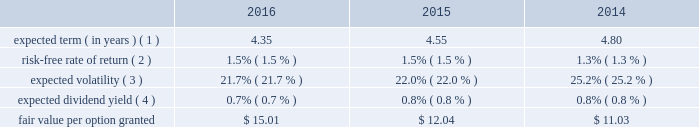Visa inc .
Notes to consolidated financial statements 2014 ( continued ) september 30 , 2016 note 16 2014share-based compensation 2007 equity incentive compensation plan the company 2019s 2007 equity incentive compensation plan , or the eip , authorizes the compensation committee of the board of directors to grant non-qualified stock options ( 201coptions 201d ) , restricted stock awards ( 201crsas 201d ) , restricted stock units ( 201crsus 201d ) and performance-based shares to its employees and non-employee directors , for up to 236 million shares of class a common stock .
Shares available for award may be either authorized and unissued or previously issued shares subsequently acquired by the company .
The eip will continue to be in effect until all of the common stock available under the eip is delivered and all restrictions on those shares have lapsed , unless the eip is terminated earlier by the company 2019s board of directors .
In january 2016 , the company 2019s board of directors approved an amendment of the eip effective february 3 , 2016 , such that awards may be granted under the plan until january 31 , 2022 .
Share-based compensation cost is recorded net of estimated forfeitures on a straight-line basis for awards with service conditions only , and on a graded-vesting basis for awards with service , performance and market conditions .
The company 2019s estimated forfeiture rate is based on an evaluation of historical , actual and trended forfeiture data .
For fiscal 2016 , 2015 and 2014 , the company recorded share-based compensation cost related to the eip of $ 211 million , $ 184 million and $ 172 million , respectively , in personnel on its consolidated statements of operations .
The related tax benefits were $ 62 million , $ 54 million and $ 51 million for fiscal 2016 , 2015 and 2014 , respectively .
The amount of capitalized share-based compensation cost was immaterial during fiscal 2016 , 2015 and all per share amounts and number of shares outstanding presented below reflect the four-for-one stock split that was effected in the second quarter of fiscal 2015 .
See note 14 2014stockholders 2019 equity .
Options options issued under the eip expire 10 years from the date of grant and primarily vest ratably over 3 years from the date of grant , subject to earlier vesting in full under certain conditions .
During fiscal 2016 , 2015 and 2014 , the fair value of each stock option was estimated on the date of grant using a black-scholes option pricing model with the following weighted-average assumptions: .
( 1 ) this assumption is based on the company 2019s historical option exercises and those of a set of peer companies that management believes is generally comparable to visa .
The company 2019s data is weighted based on the number of years between the measurement date and visa 2019s initial public offering as a percentage of the options 2019 contractual term .
The relative weighting placed on visa 2019s data and peer data in fiscal 2016 was approximately 77% ( 77 % ) and 23% ( 23 % ) , respectively , 67% ( 67 % ) and 33% ( 33 % ) in fiscal 2015 , respectively , and 58% ( 58 % ) and 42% ( 42 % ) in fiscal 2014 , respectively. .
What is the percent change in fair value per option granted from 2015 to 2016? 
Computations: (15.01 - 12.04)
Answer: 2.97. 